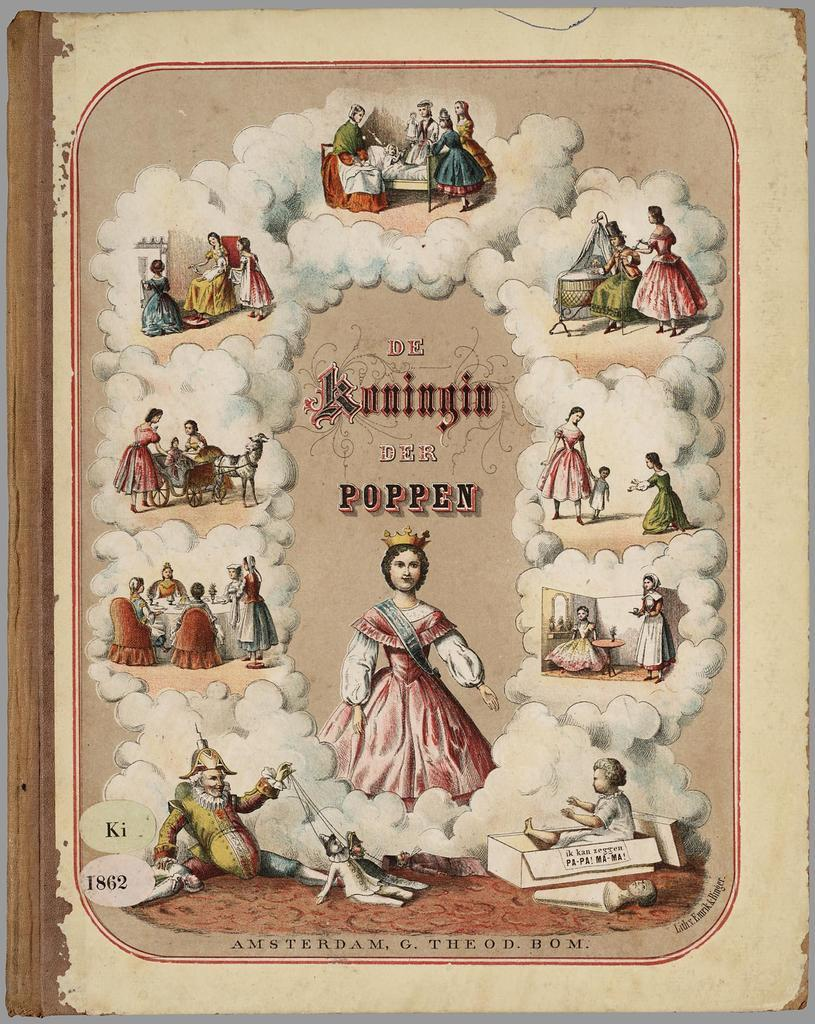What is present in the image? There is a poster in the image. What can be seen on the poster? The poster contains images of persons. What type of square is featured in the image? There is no square present in the image; it contains a poster with images of persons. 